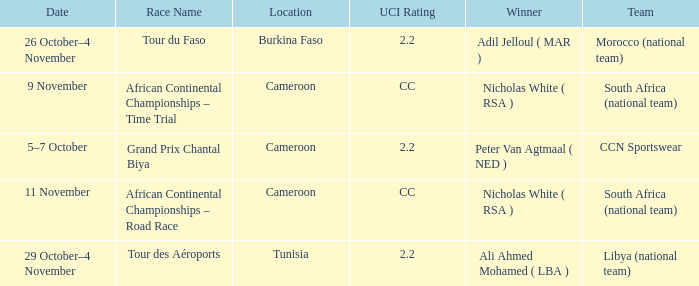Who is the winner of the race in Burkina Faso? Adil Jelloul ( MAR ). 